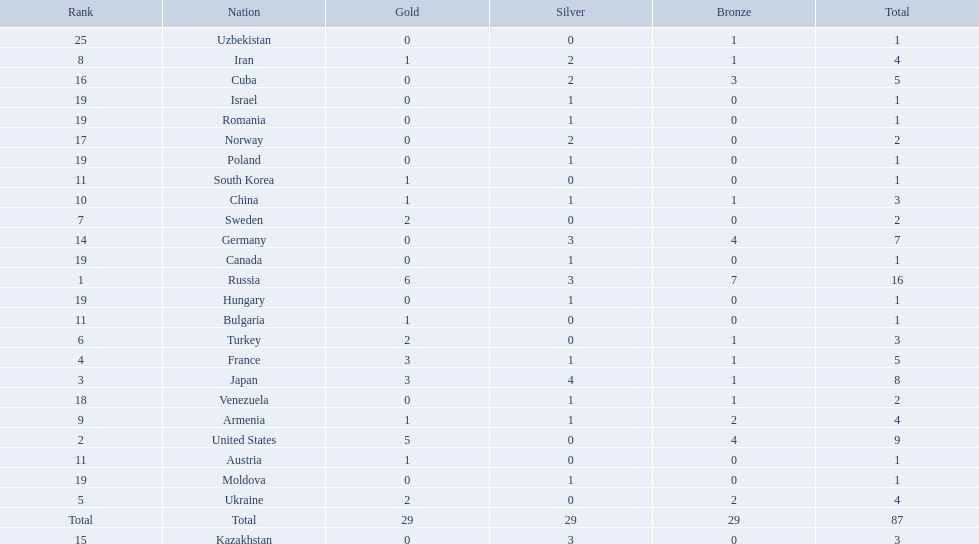Which nations participated in the 1995 world wrestling championships? Russia, United States, Japan, France, Ukraine, Turkey, Sweden, Iran, Armenia, China, Austria, Bulgaria, South Korea, Germany, Kazakhstan, Cuba, Norway, Venezuela, Canada, Hungary, Israel, Moldova, Poland, Romania, Uzbekistan. And between iran and germany, which one placed in the top 10? Germany. What was iran's ranking? 8. What was germany's ranking? 14. Between iran and germany, which was not in the top 10? Germany. 